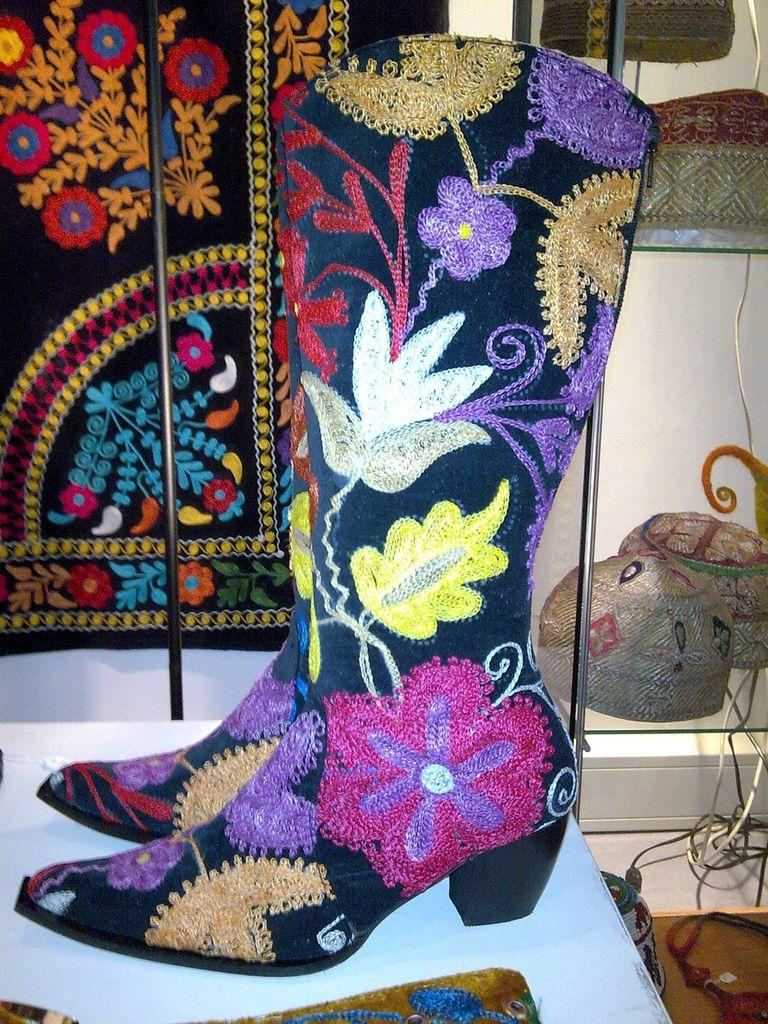What type of footwear is visible in the image? There is a pair of boots in the image. Where are the boots placed in the image? The boots are on an object. Can you describe the background of the image? There are items in the background of the image. What type of string is being used by the committee in the image? There is no committee or string present in the image; it only features a pair of boots on an object with items in the background. 